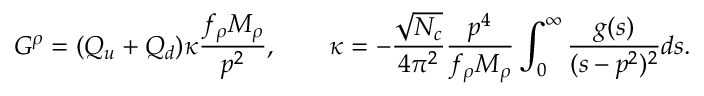<formula> <loc_0><loc_0><loc_500><loc_500>G ^ { \rho } = ( Q _ { u } + Q _ { d } ) \kappa \frac { f _ { \rho } M _ { \rho } } { p ^ { 2 } } , \quad \kappa = - \frac { \sqrt { N _ { c } } } { 4 \pi ^ { 2 } } \frac { p ^ { 4 } } { f _ { \rho } M _ { \rho } } \int _ { 0 } ^ { \infty } \frac { g ( s ) } { ( s - p ^ { 2 } ) ^ { 2 } } d s .</formula> 